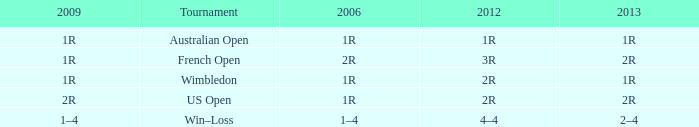What is the 2006 when the 2013 is 1r, and the 2012 is 1r? 1R. 